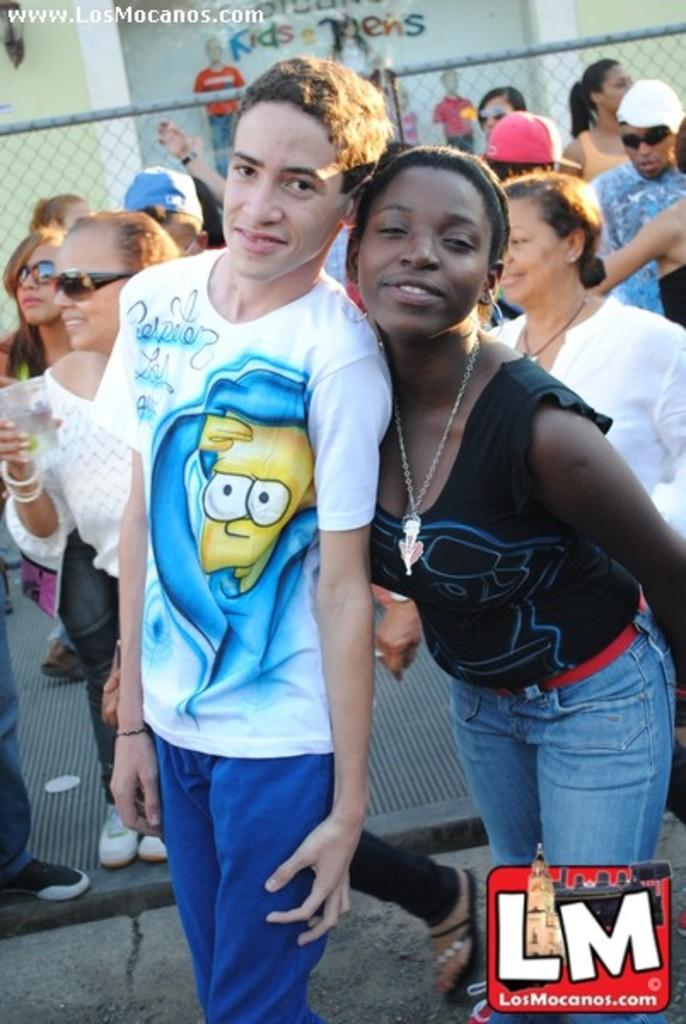What are the people in the image doing? The people in the image are standing and walking. What type of barrier is present in the image? There is a metal rod fence in the image. What can be seen on the other side of the fence? There is a wall with mannequins on the other side of the fence. Where are the cows grazing in the image? There are no cows present in the image. Can you tell me how many monkeys are sitting on the wall in the image? There are no monkeys present in the image; it features a wall with mannequins. 